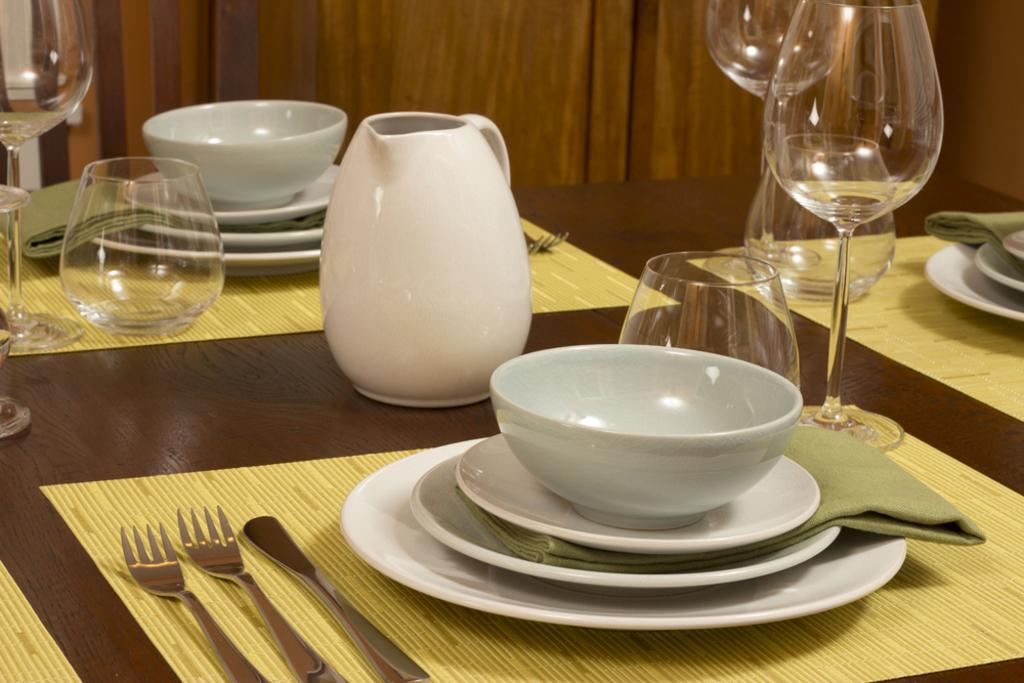How many water glasses are visible in the image? There are four empty water glasses in the image. What else can be seen on the table besides the water glasses? There are plates, a bowl, a cloth, two forks, and one knife visible in the image. What type of material is the cloth made of? The cloth on the dining table is made of fabric. What is the wooden panel visible in the image used for? The wooden panel visible in the image is likely part of the dining table or furniture. How many giraffes are present in the image? There are no giraffes present in the image. What type of plants can be seen growing on the plates in the image? There are no plants visible on the plates in the image. 